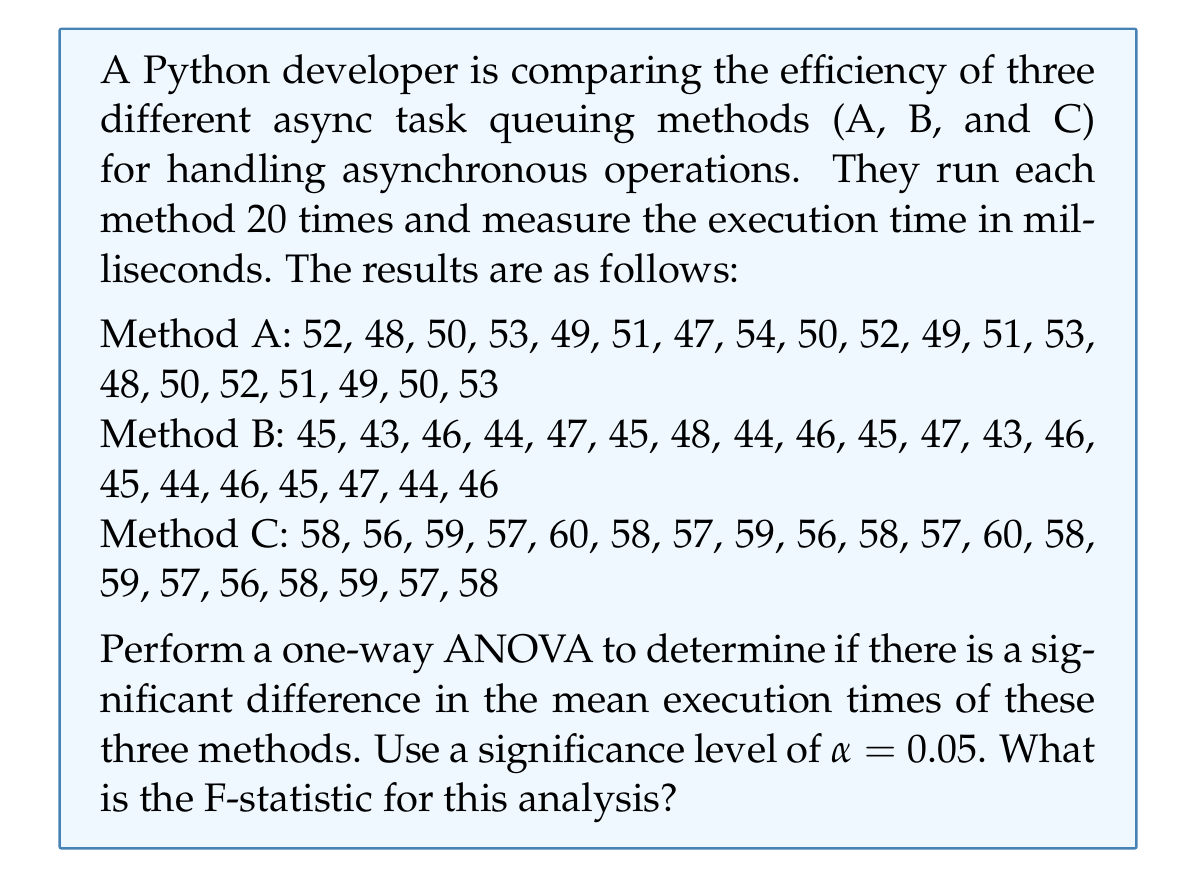Provide a solution to this math problem. To perform a one-way ANOVA, we need to follow these steps:

1. Calculate the means for each method:
   $\bar{X}_A = 50.60$
   $\bar{X}_B = 45.30$
   $\bar{X}_C = 57.85$

2. Calculate the grand mean:
   $\bar{X} = \frac{50.60 + 45.30 + 57.85}{3} = 51.25$

3. Calculate the Sum of Squares Between (SSB):
   $$SSB = \sum_{i=1}^{k} n_i (\bar{X}_i - \bar{X})^2$$
   where $k$ is the number of groups (3) and $n_i$ is the number of observations in each group (20).
   
   $SSB = 20[(50.60 - 51.25)^2 + (45.30 - 51.25)^2 + (57.85 - 51.25)^2]$
   $SSB = 1561.30$

4. Calculate the Sum of Squares Within (SSW):
   $$SSW = \sum_{i=1}^{k} \sum_{j=1}^{n_i} (X_{ij} - \bar{X}_i)^2$$
   
   For Method A: $SSW_A = 86.80$
   For Method B: $SSW_B = 44.20$
   For Method C: $SSW_C = 44.55$
   
   $SSW = 86.80 + 44.20 + 44.55 = 175.55$

5. Calculate the degrees of freedom:
   $df_{between} = k - 1 = 3 - 1 = 2$
   $df_{within} = N - k = 60 - 3 = 57$
   where $N$ is the total number of observations.

6. Calculate the Mean Square Between (MSB) and Mean Square Within (MSW):
   $MSB = \frac{SSB}{df_{between}} = \frac{1561.30}{2} = 780.65$
   $MSW = \frac{SSW}{df_{within}} = \frac{175.55}{57} = 3.08$

7. Calculate the F-statistic:
   $$F = \frac{MSB}{MSW} = \frac{780.65}{3.08} = 253.46$$

The F-statistic for this analysis is 253.46.
Answer: $F = 253.46$ 